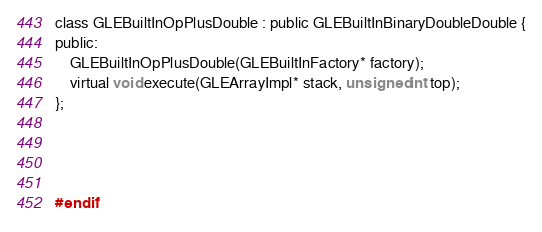<code> <loc_0><loc_0><loc_500><loc_500><_C_>
class GLEBuiltInOpPlusDouble : public GLEBuiltInBinaryDoubleDouble {
public:
	GLEBuiltInOpPlusDouble(GLEBuiltInFactory* factory);
	virtual void execute(GLEArrayImpl* stack, unsigned int top);
};




#endif
</code> 